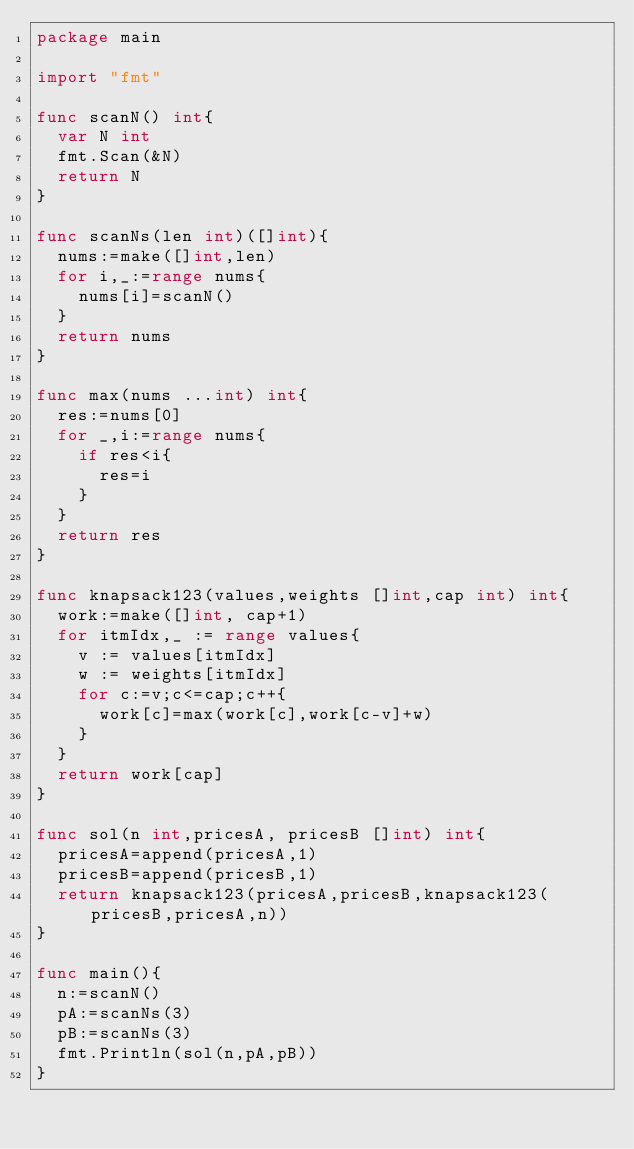Convert code to text. <code><loc_0><loc_0><loc_500><loc_500><_Go_>package main

import "fmt"

func scanN() int{
	var N int
	fmt.Scan(&N)
	return N
}

func scanNs(len int)([]int){
	nums:=make([]int,len)
	for i,_:=range nums{
		nums[i]=scanN()
	}
	return nums
}

func max(nums ...int) int{
	res:=nums[0]
	for _,i:=range nums{
		if res<i{
			res=i
		}
	}
	return res
}

func knapsack123(values,weights []int,cap int) int{
	work:=make([]int, cap+1)
	for itmIdx,_ := range values{
		v := values[itmIdx]
		w := weights[itmIdx]
		for c:=v;c<=cap;c++{
			work[c]=max(work[c],work[c-v]+w)
		}
	}
	return work[cap]
}

func sol(n int,pricesA, pricesB []int) int{
	pricesA=append(pricesA,1)
	pricesB=append(pricesB,1)
	return knapsack123(pricesA,pricesB,knapsack123(pricesB,pricesA,n))
}

func main(){
	n:=scanN()
	pA:=scanNs(3)
	pB:=scanNs(3)
	fmt.Println(sol(n,pA,pB))
}</code> 